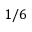<formula> <loc_0><loc_0><loc_500><loc_500>1 / 6</formula> 